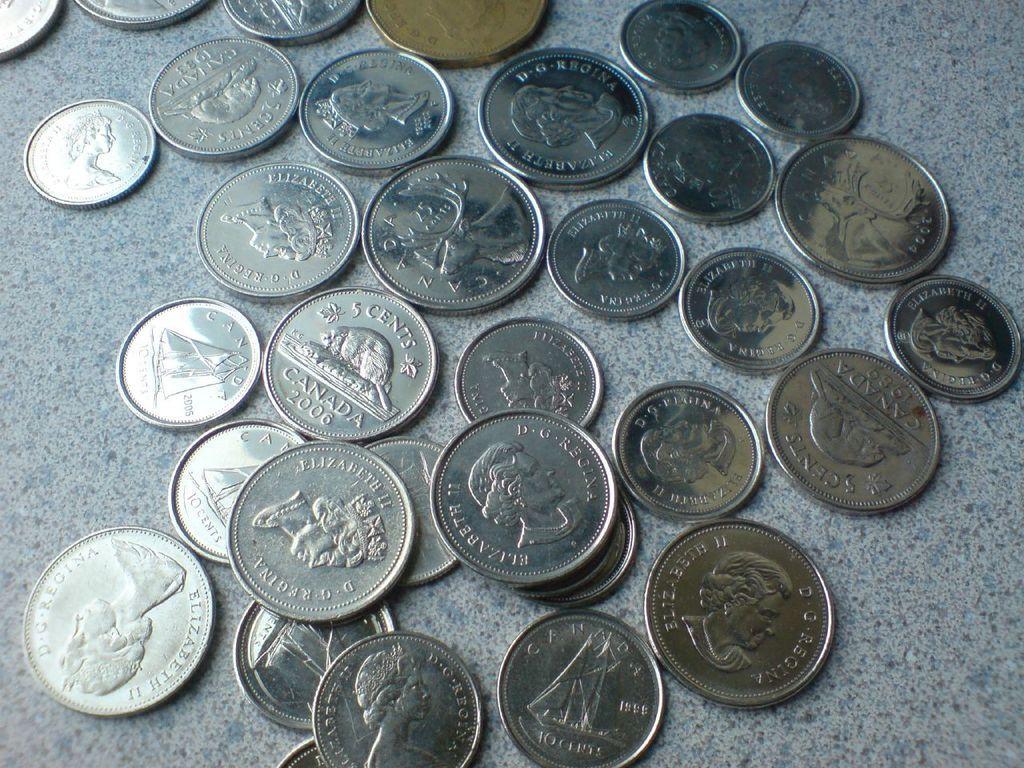Please provide a concise description of this image. In this image we can see some currency coins on the floor. 